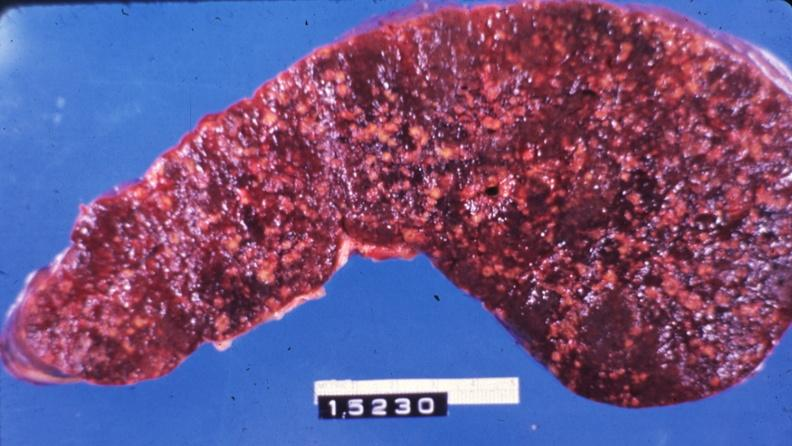what is present?
Answer the question using a single word or phrase. Hematologic 